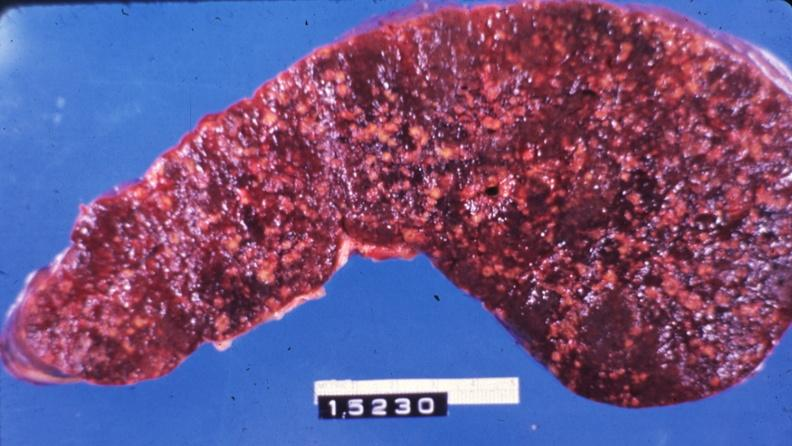what is present?
Answer the question using a single word or phrase. Hematologic 